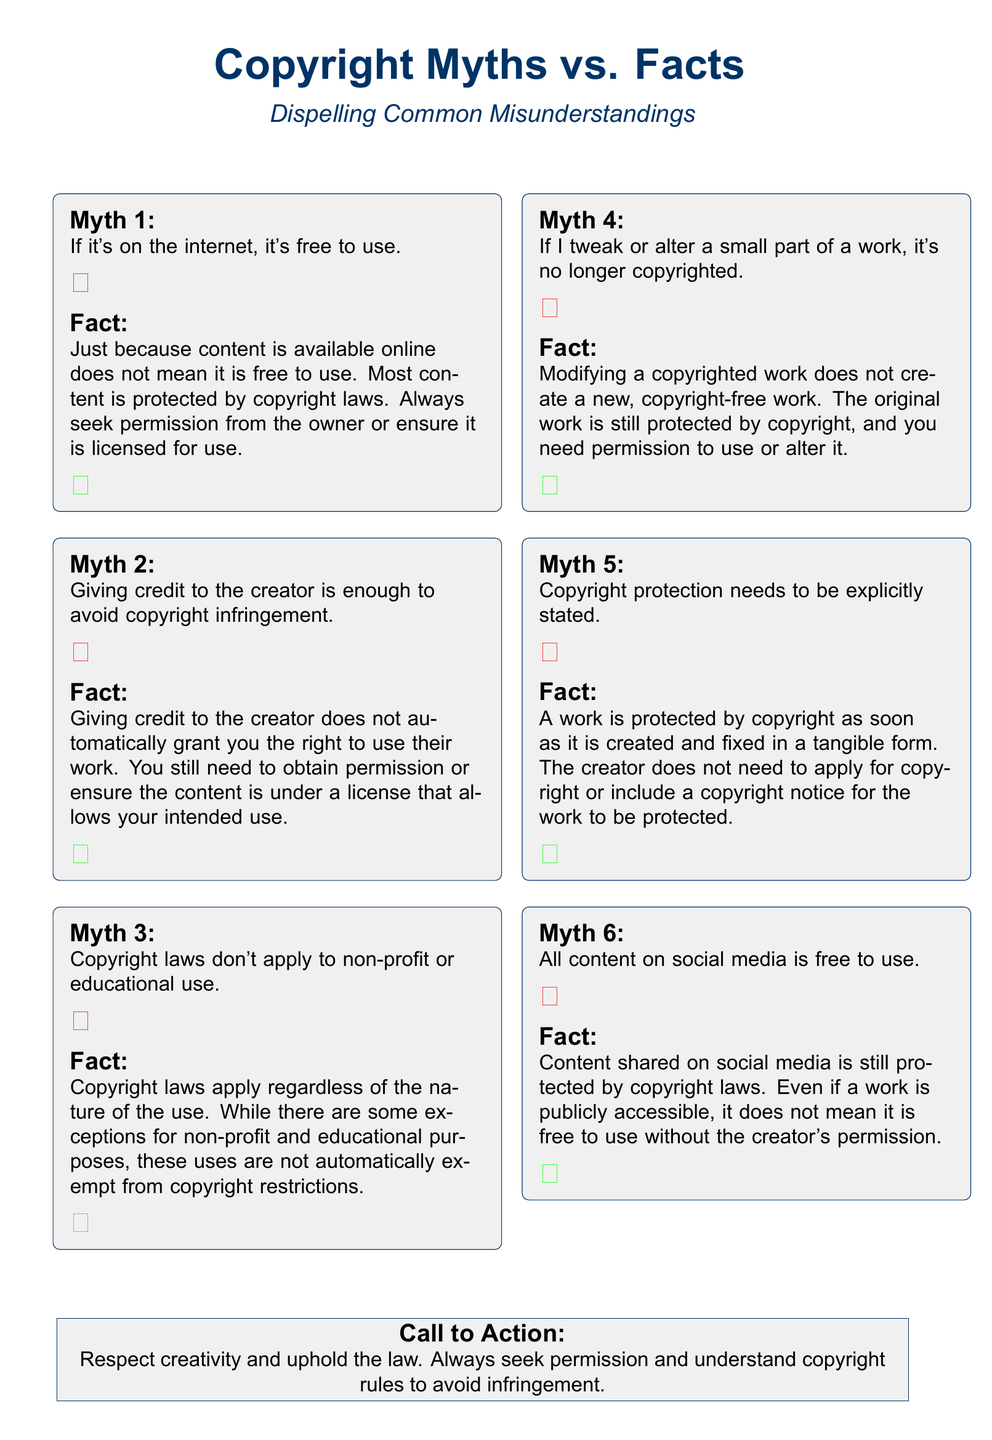What is the main title of the document? The main title is prominently displayed at the top of the flyer as "Copyright Myths vs. Facts."
Answer: Copyright Myths vs. Facts How many myths are listed in the document? The document contains six myths related to copyright.
Answer: 6 What color is used for the checkmark symbol? The checkmark symbol is represented in green color in the document.
Answer: Green What does the flyer encourage people to do at the end? The flyer includes a call to action encouraging individuals to respect creativity and understand copyright rules.
Answer: Respect creativity and uphold the law Which website is suggested for more information on copyright? The document provides the U.S. Copyright Office's website for additional information.
Answer: www.copyright.gov What is the design color associated with the headlines in the document? The design color used for the headlines and borders in the document is law blue.
Answer: Law blue 